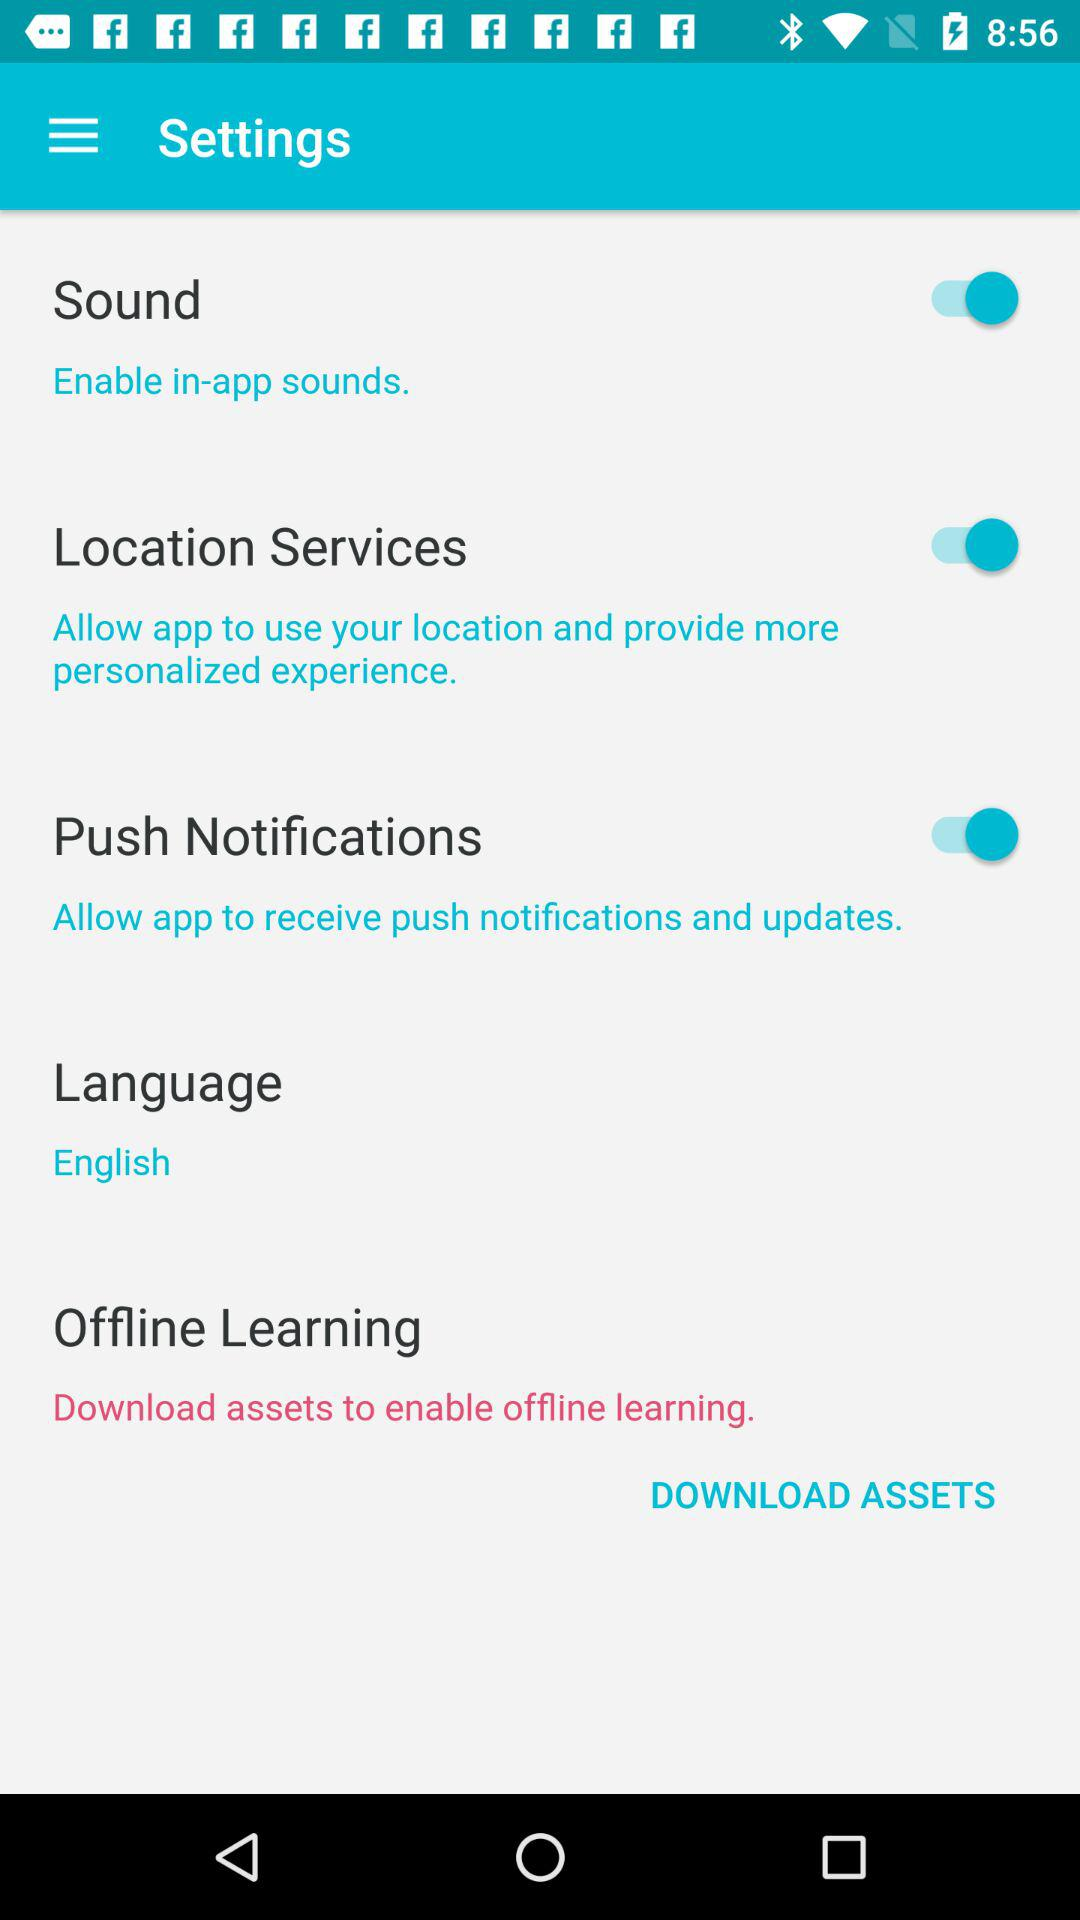What is the status of "Location Services"? The status is "on". 